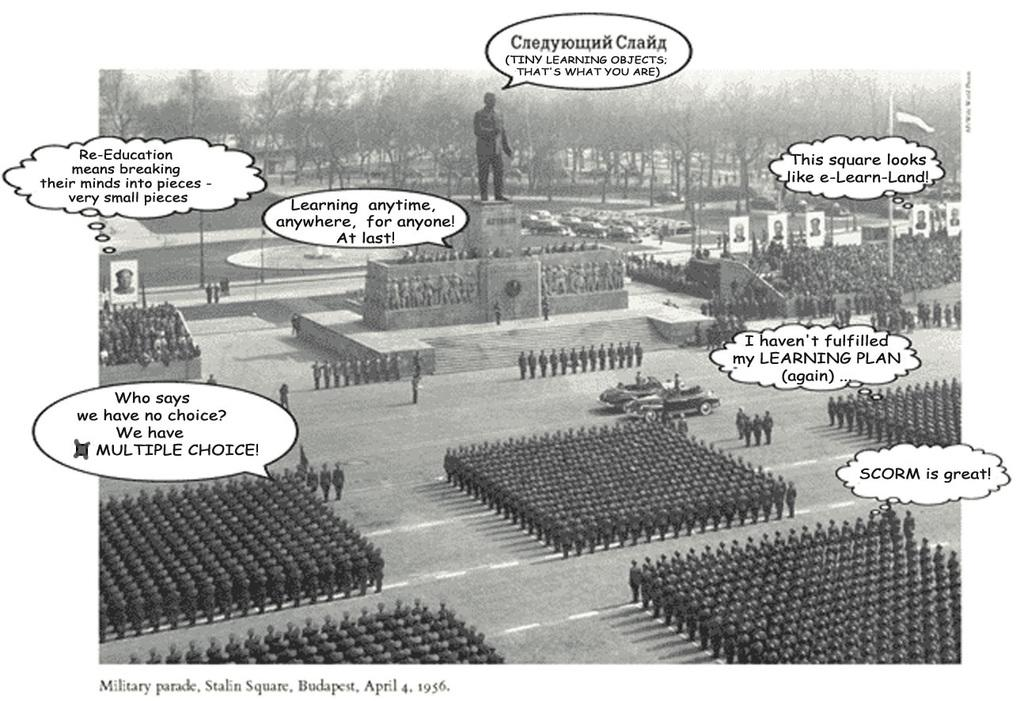Who or what can be seen in the image? There are persons in the image. What else is present in the image besides the persons? There is some text, cars, a statue, and trees in the image. Can you describe the location of the cars in the image? The cars are in the middle of the image. What is the statue of in the image? The specific statue and its subject are not mentioned in the provided facts, so we cannot determine what it is of. What type of vegetation is visible at the top of the image? There are trees at the top of the image. What is the average income of the persons in the image? There is no information about the income of the persons in the image, so we cannot determine their average income. What type of flag is visible in the image? There is no flag present in the image. 